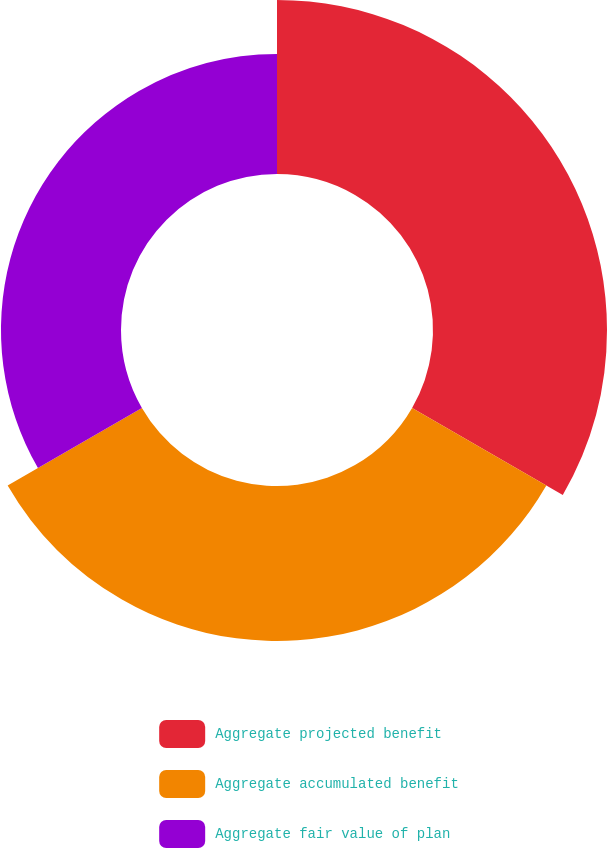<chart> <loc_0><loc_0><loc_500><loc_500><pie_chart><fcel>Aggregate projected benefit<fcel>Aggregate accumulated benefit<fcel>Aggregate fair value of plan<nl><fcel>38.75%<fcel>34.52%<fcel>26.73%<nl></chart> 